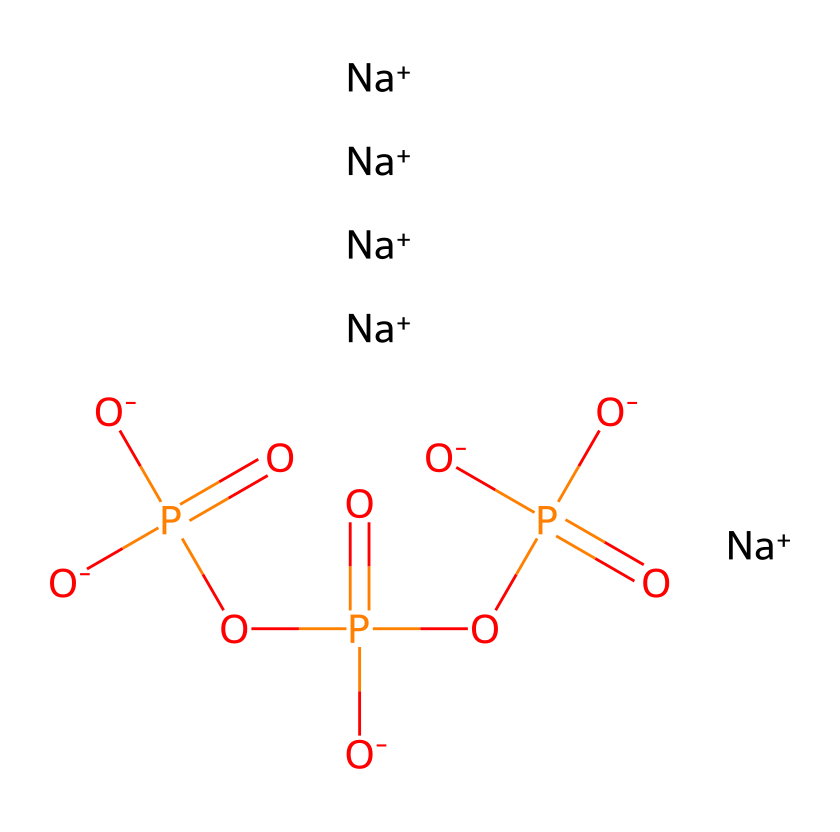What is the molecular formula of sodium tripolyphosphate? By analyzing the SMILES representation, we can count the atoms of each element present. From the structure, we can see there are 3 phosphorus atoms, 10 oxygen atoms, and 5 sodium atoms. Therefore, the molecular formula can be constructed as Na5P3O10.
Answer: Na5P3O10 How many sodium ions are present in sodium tripolyphosphate? The SMILES representation indicates five sodium ions; they are represented as [Na+] and explicitly listed in the chemical structure.
Answer: 5 What type of phosphorus compound is sodium tripolyphosphate? Sodium tripolyphosphate is classified as a polyphosphate due to the presence of multiple phosphate groups linked together in its structure, specifically featuring three phosphorus atoms linked by oxygen atoms.
Answer: polyphosphate How many phosphate groups are there in sodium tripolyphosphate? In the SMILES, there are three phosphorus atoms, and each phosphorus atom is part of a phosphate group. Thus, there are three phosphate groups in total.
Answer: 3 What is the oxidation state of phosphorus in this compound? In sodium tripolyphosphate, the phosphorus atoms are in the +5 oxidation state, which is characteristic of phosphate groups. This can be determined by considering the bonding and typical oxidation states of phosphorus.
Answer: +5 What is the total charge of the sodium tripolyphosphate molecule? The compound contains five sodium ions, each with a +1 charge, contributing a total of +5 charge. All the oxygen atoms are negatively charged, yielding a total of -10 charge for the phosphate groups. Hence, the overall charge of the compound is neutral (0).
Answer: 0 